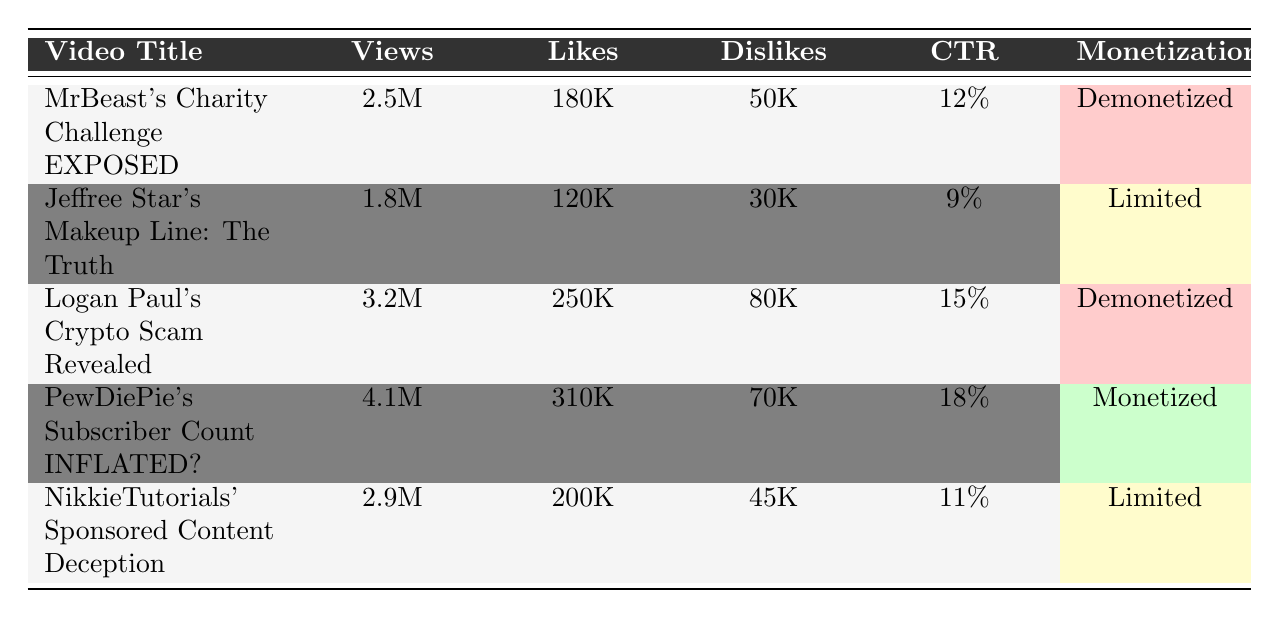What is the video with the highest number of views? By examining the "Views" column in the table, "PewDiePie's Subscriber Count INFLATED?" has the highest view count at 4.1 million.
Answer: 4.1 million Which video has the most likes? Looking at the "Likes" column, "PewDiePie's Subscriber Count INFLATED?" has the highest likes with 310,000.
Answer: 310,000 What is the total number of dislikes for all the videos? Summing the "Dislikes" values: 50,000 + 30,000 + 80,000 + 70,000 + 45,000 = 275,000.
Answer: 275,000 Determine the video with the lowest click-through rate (CTR). The "CTR" column shows "Jeffree Star's Makeup Line: The Truth" has the lowest CTR at 9%.
Answer: 9% Which video has the highest ratio of likes to dislikes? Calculate the ratio for each video: "MrBeast's Charity Challenge EXPOSED" = 180K/50K = 3.6, "Jeffree Star's Makeup Line: The Truth" = 120K/30K = 4, “Logan Paul’s Crypto Scam Revealed” = 250K/80K = 3.125, "PewDiePie's Subscriber Count INFLATED?" = 310K/70K = 4.43, "NikkieTutorials’ Sponsored Content Deception" = 200K/45K = 4.44. "PewDiePie’s Subscriber Count INFLATED?" has the highest ratio at approximately 4.43.
Answer: "PewDiePie’s Subscriber Count INFLATED?" Is Logan Paul's video monetized? According to the "Monetization" column, Logan Paul's video is labeled "Demonetized."
Answer: No What is the average number of shares across the videos? Sum the "Shares": 35,000 + 22,000 + 48,000 + 60,000 + 40,000 = 205,000, and divide by 5 (total videos) gives an average of 41,000.
Answer: 41,000 Which video had the most significant subscriber loss? Checking the "Subscriber Loss" column, "PewDiePie's Subscriber Count INFLATED?" shows a subscriber loss of 10,000, which is the highest.
Answer: 10,000 Identify the video with the highest watch time. The "Watch Time Minutes" column indicates "PewDiePie's Subscriber Count INFLATED?" has the highest watch time at 12,300,000 minutes.
Answer: 12,300,000 minutes Which video has limited monetization, and how many views did it receive? In the "Monetization" column, both "Jeffree Star's Makeup Line: The Truth" and "NikkieTutorials' Sponsored Content Deception" have "Limited" status. Their views are 1.8 million and 2.9 million, respectively.
Answer: 1.8 million and 2.9 million Calculate the percentage of dislikes relative to views for "MrBeast's Charity Challenge EXPOSED." The calculation is (50K / 2.5M) * 100, which gives 2%. This means 2% of viewers disliked the video.
Answer: 2% 